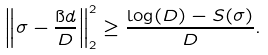<formula> <loc_0><loc_0><loc_500><loc_500>\left \| \sigma - \frac { \i d } { D } \right \| _ { 2 } ^ { 2 } \geq \frac { \log ( D ) - S ( \sigma ) } { D } .</formula> 